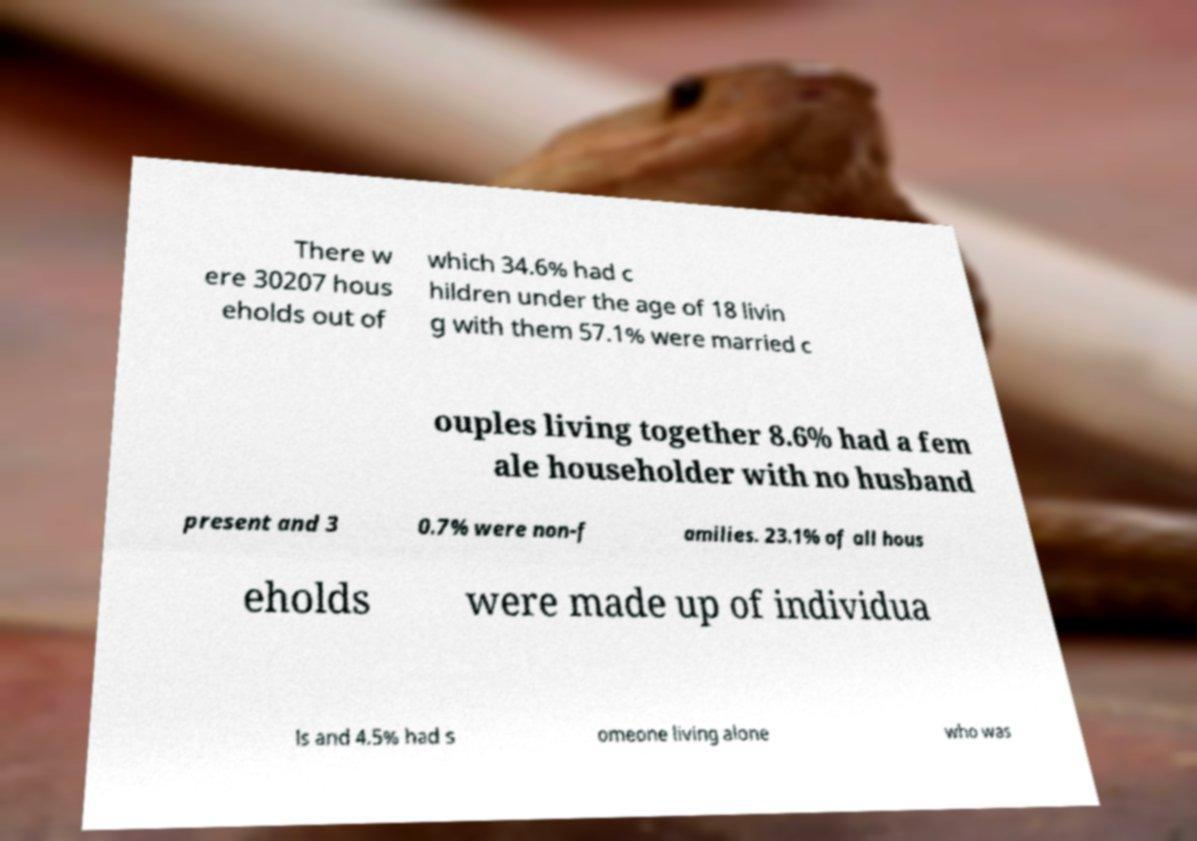There's text embedded in this image that I need extracted. Can you transcribe it verbatim? There w ere 30207 hous eholds out of which 34.6% had c hildren under the age of 18 livin g with them 57.1% were married c ouples living together 8.6% had a fem ale householder with no husband present and 3 0.7% were non-f amilies. 23.1% of all hous eholds were made up of individua ls and 4.5% had s omeone living alone who was 